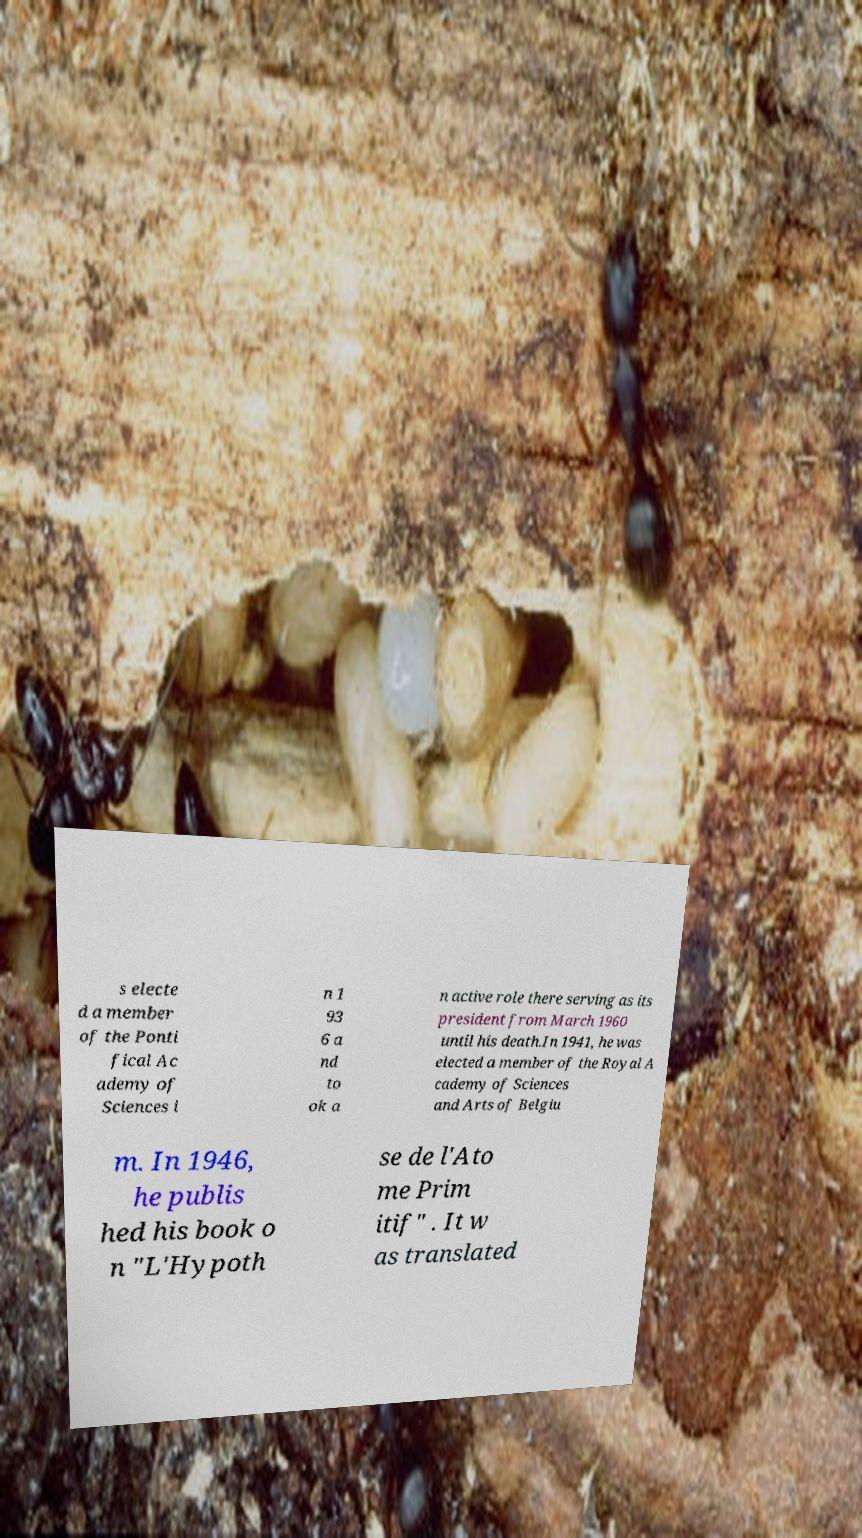There's text embedded in this image that I need extracted. Can you transcribe it verbatim? s electe d a member of the Ponti fical Ac ademy of Sciences i n 1 93 6 a nd to ok a n active role there serving as its president from March 1960 until his death.In 1941, he was elected a member of the Royal A cademy of Sciences and Arts of Belgiu m. In 1946, he publis hed his book o n "L'Hypoth se de l'Ato me Prim itif" . It w as translated 